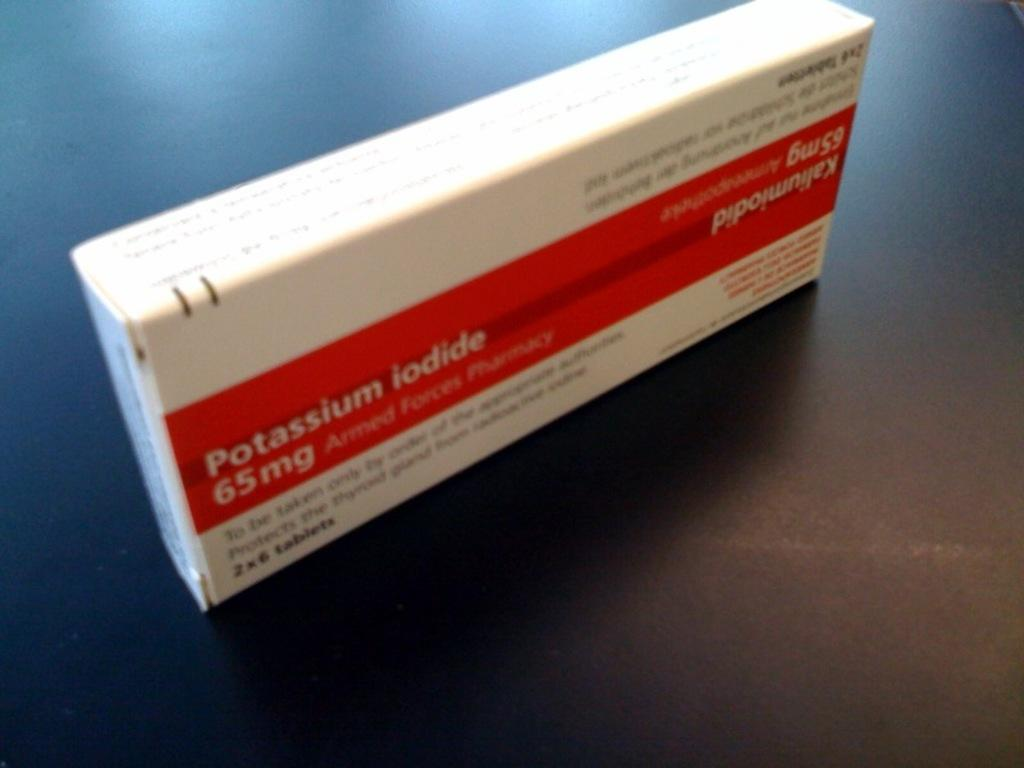<image>
Give a short and clear explanation of the subsequent image. A white and red box of 65mg Potassium iodide tablets. 